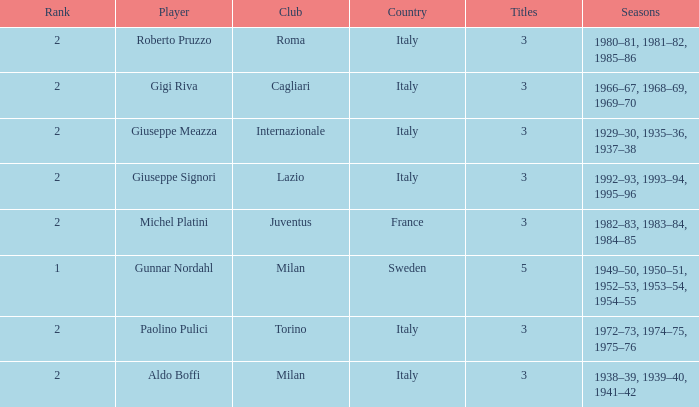How many rankings are associated with giuseppe meazza holding over 3 titles? 0.0. 